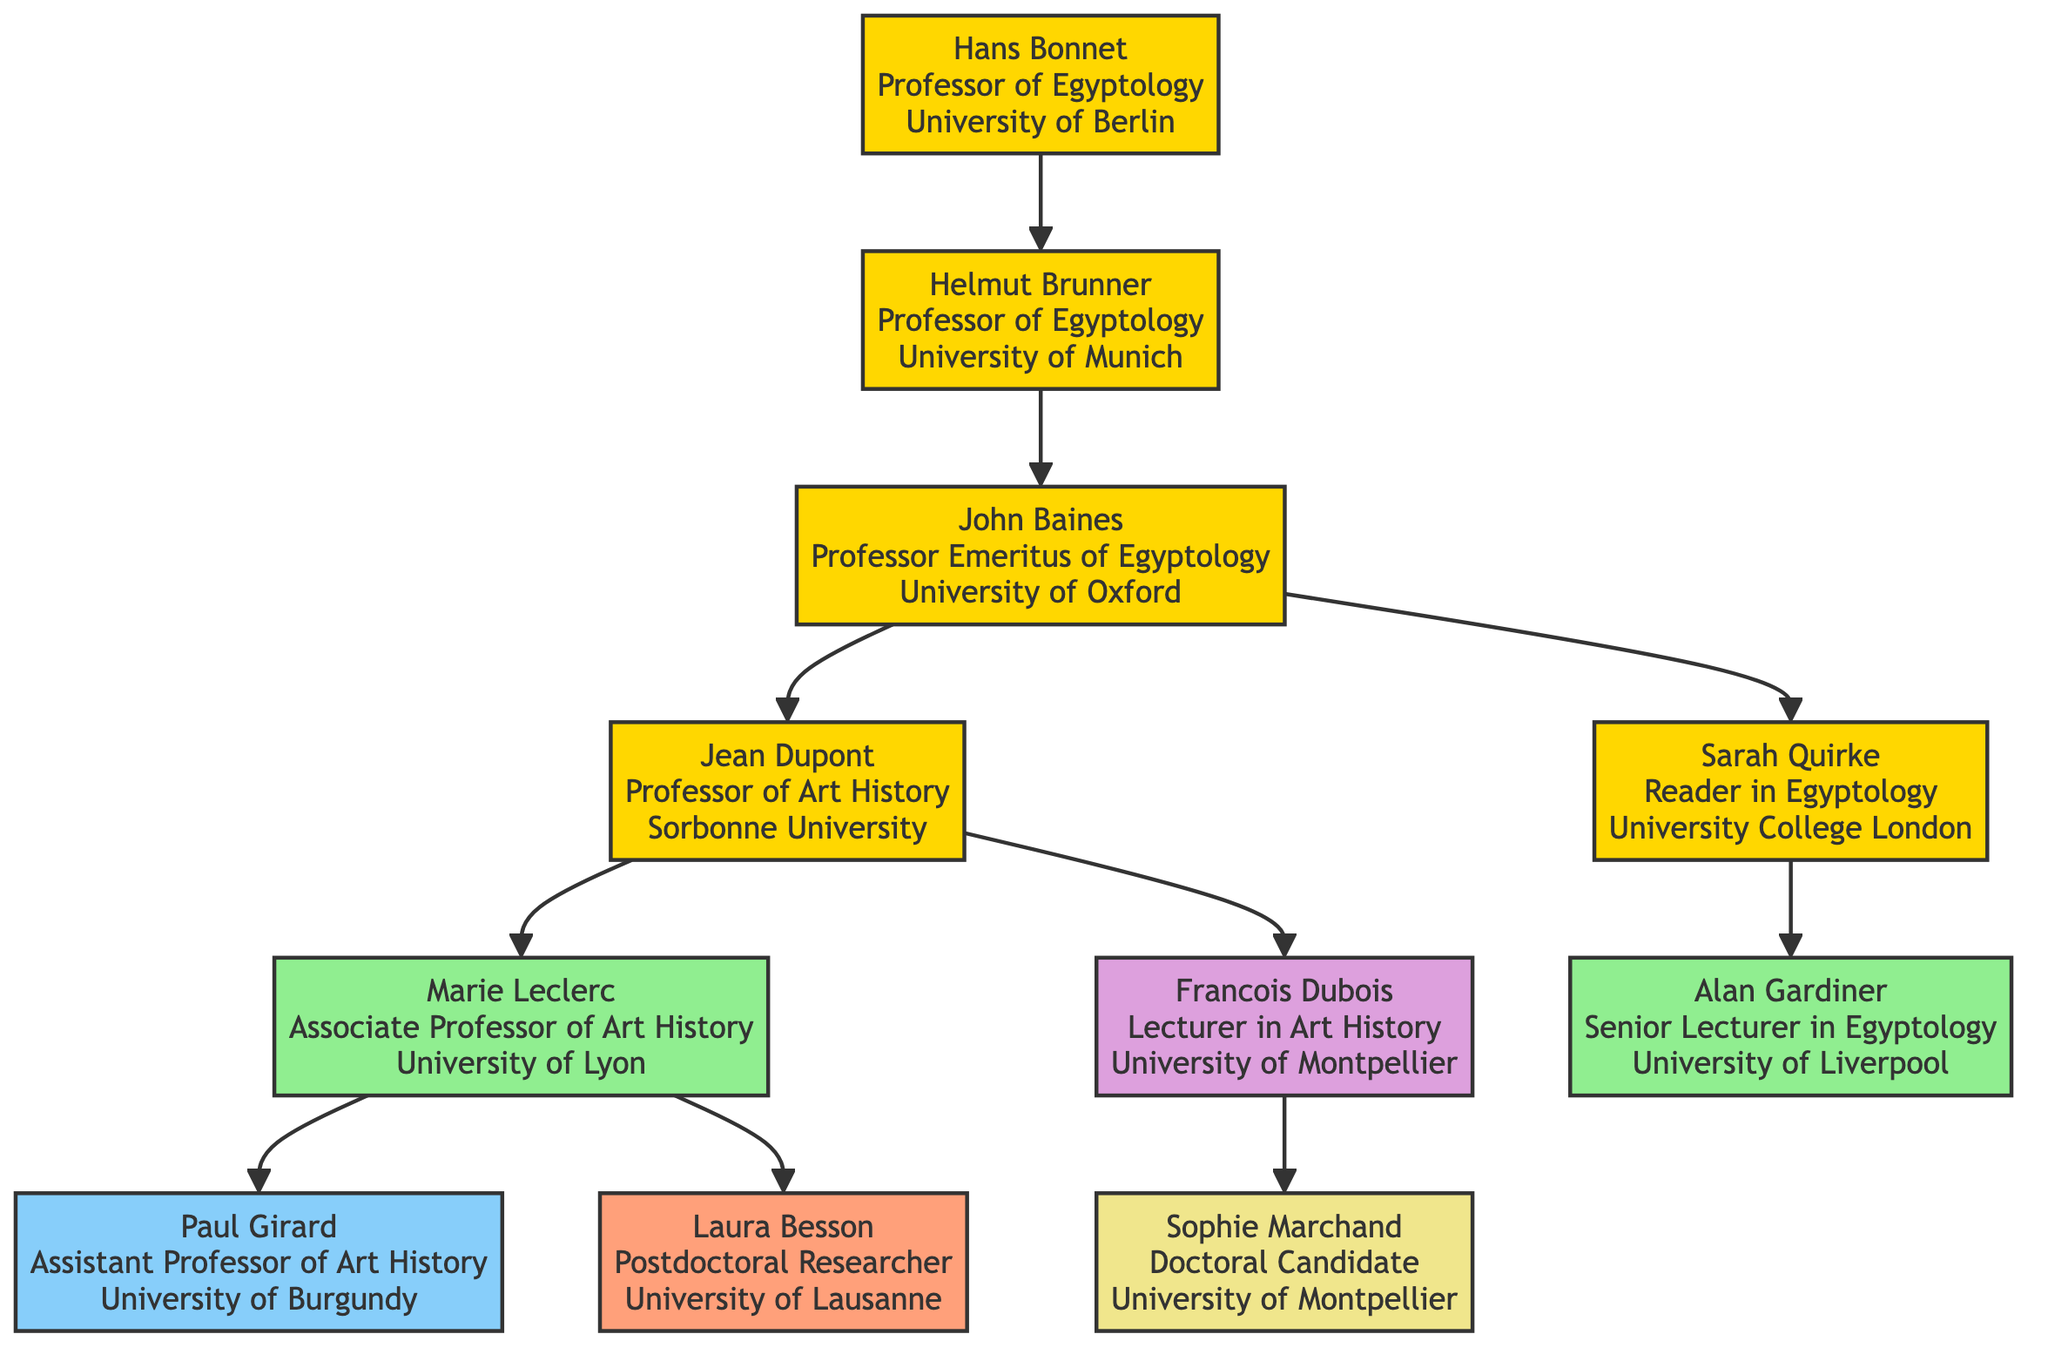What is the title of Jean Dupont? Jean Dupont's title is clearly stated in the diagram as "Professor of Art History, Specializing in Ancient Egyptian Art."
Answer: Professor of Art History, Specializing in Ancient Egyptian Art How many students does Marie Leclerc have? Maria Leclerc has two listed students: Paul Girard and Laura Besson. Hence, we can count them to find that she has two students.
Answer: 2 Who is the mentor of John Baines? In the diagram, John Baines is shown to have Helmut Brunner as his mentor. The relationship is indicated by the connection between their nodes.
Answer: Helmut Brunner What institution is Francois Dubois affiliated with? The chart specifies Francois Dubois's institution as "University of Montpellier," directly under his node.
Answer: University of Montpellier How many total professors are mentioned in the diagram? We can count the labeled nodes that represent professors: Hans Bonnet, Helmut Brunner, John Baines, and Jean Dupont, resulting in a total of four.
Answer: 4 Which student of John Baines has a more advanced title, Associate Professor or Reader? By examining the chart, Sarah Quirke is labeled as a Reader in Egyptology, while Marie Leclerc is an Associate Professor of Art History. Since Reader is a higher academic title than Associate Professor, Sarah Quirke has the more advanced title.
Answer: Reader Which student is listed as a doctoral candidate? Among the students listed, Sophie Marchand is specifically labeled as a Doctoral Candidate under Francois Dubois's mentorship.
Answer: Sophie Marchand Who are the two students of Jean Dupont? The diagram directly indicates that Jean Dupont has two students: Marie Leclerc and Francois Dubois, shown branching from his node.
Answer: Marie Leclerc, Francois Dubois Which two students are affiliated with the University of Lyon? Looking at the diagram, only Marie Leclerc is affiliated with the University of Lyon as a student under Jean Dupont. Thus, there is only one student from that institution.
Answer: Marie Leclerc 